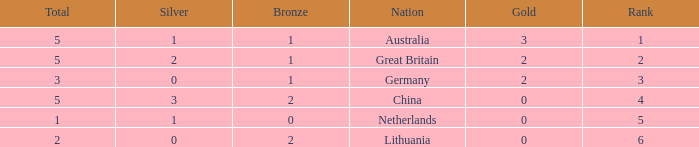What is the number for rank when gold is less than 0? None. 